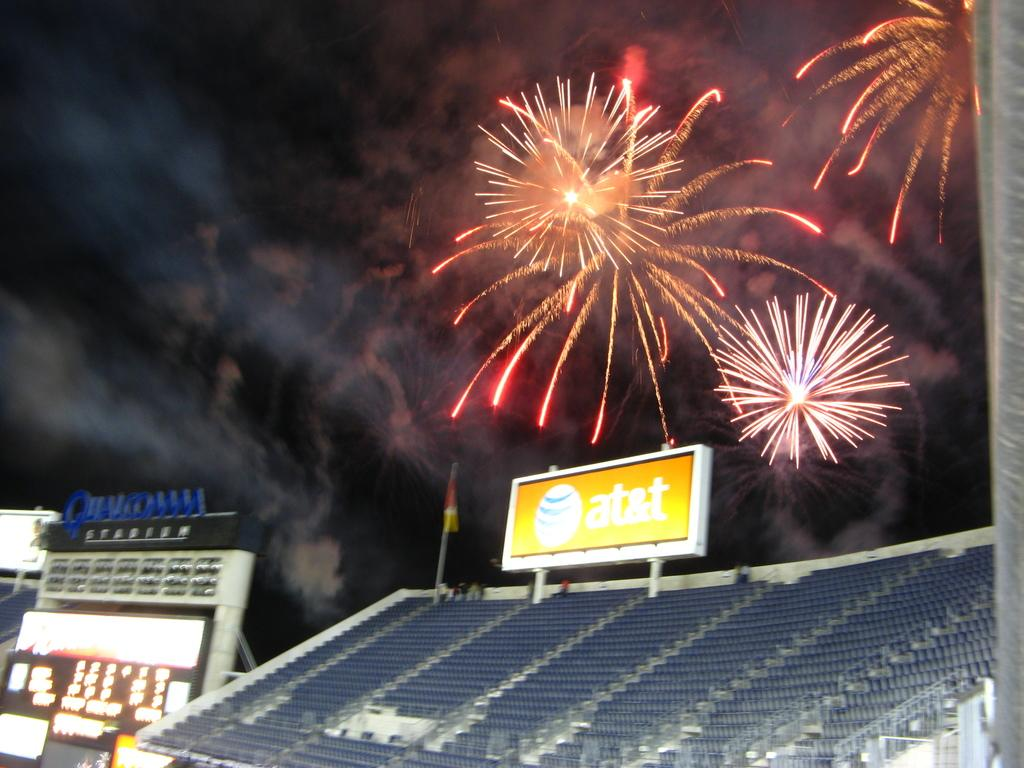<image>
Relay a brief, clear account of the picture shown. Fireworks going off over stadium seating and a lit up AT&T billboard. 